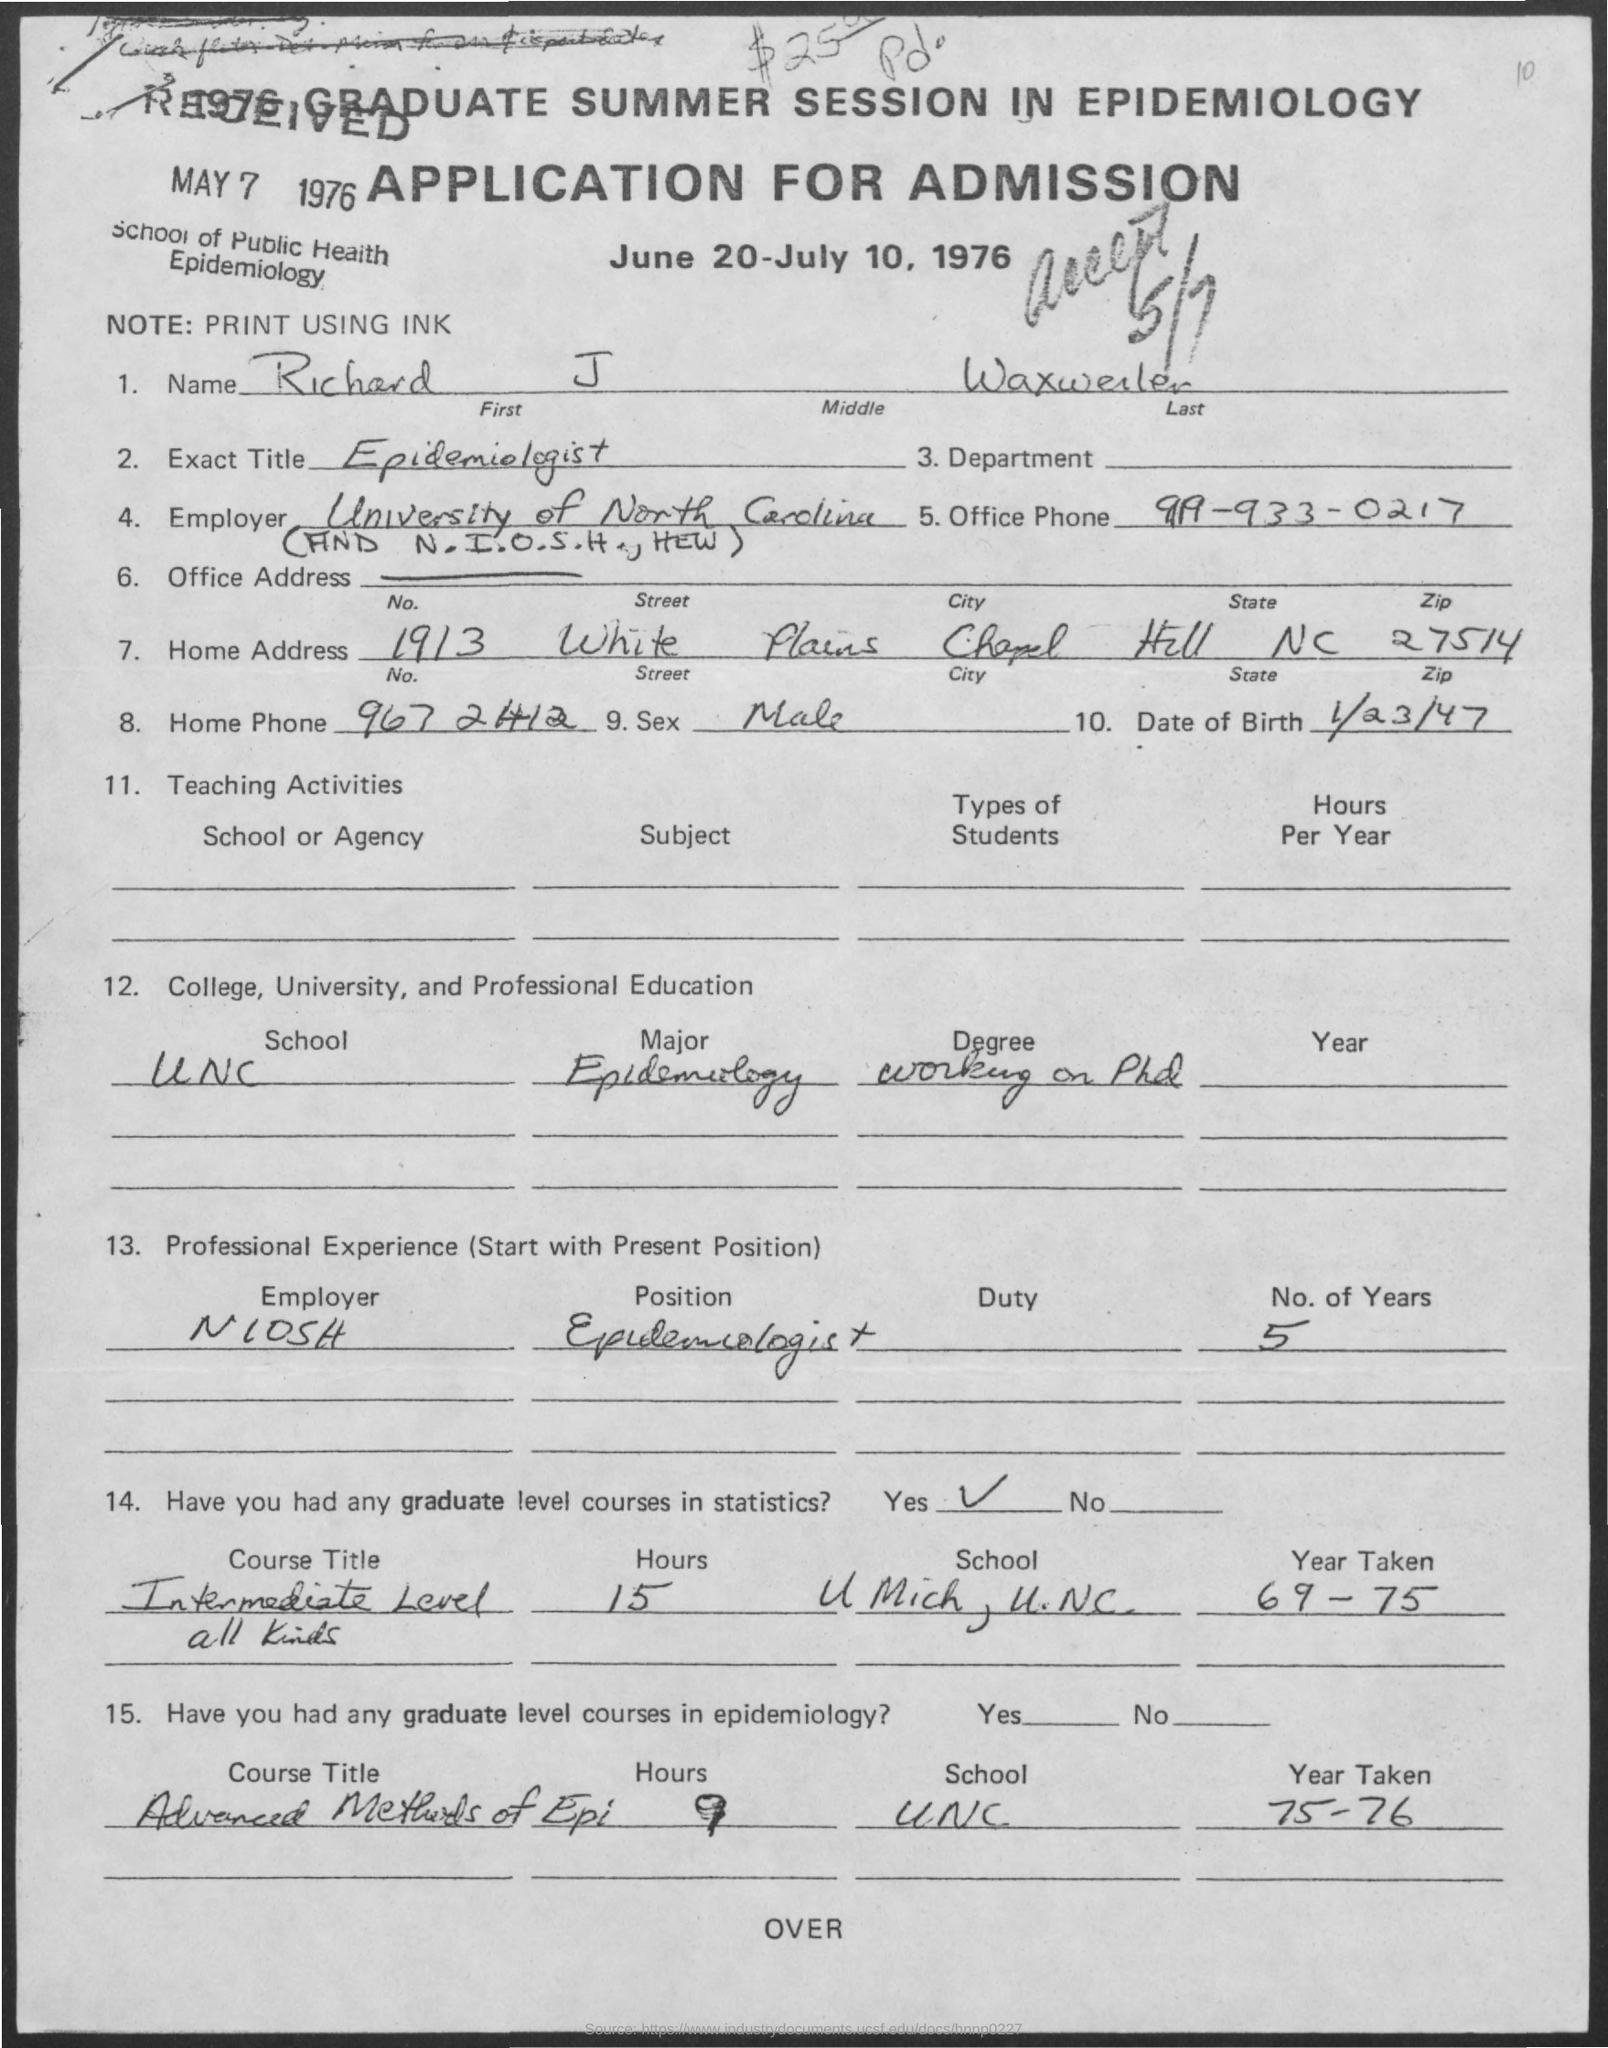What is sex?
Your answer should be compact. Male. What is date of Birth of applicant?
Offer a very short reply. 1/23/47. 